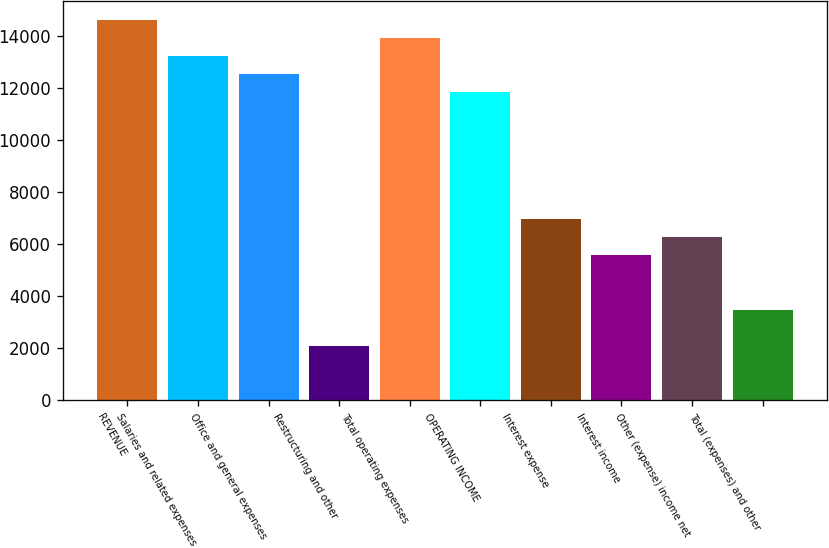<chart> <loc_0><loc_0><loc_500><loc_500><bar_chart><fcel>REVENUE<fcel>Salaries and related expenses<fcel>Office and general expenses<fcel>Restructuring and other<fcel>Total operating expenses<fcel>OPERATING INCOME<fcel>Interest expense<fcel>Interest income<fcel>Other (expense) income net<fcel>Total (expenses) and other<nl><fcel>14607.8<fcel>13216.6<fcel>12521<fcel>2087.04<fcel>13912.2<fcel>11825.4<fcel>6956.24<fcel>5565.04<fcel>6260.64<fcel>3478.24<nl></chart> 